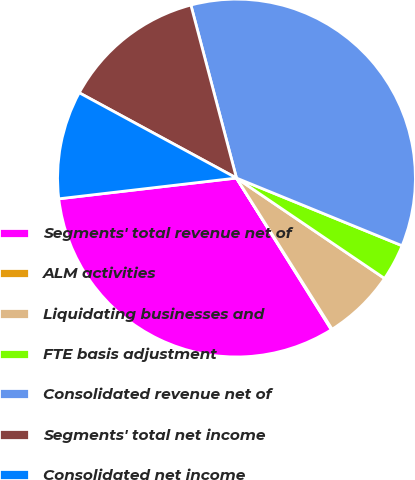<chart> <loc_0><loc_0><loc_500><loc_500><pie_chart><fcel>Segments' total revenue net of<fcel>ALM activities<fcel>Liquidating businesses and<fcel>FTE basis adjustment<fcel>Consolidated revenue net of<fcel>Segments' total net income<fcel>Consolidated net income<nl><fcel>32.05%<fcel>0.08%<fcel>6.54%<fcel>3.31%<fcel>35.28%<fcel>12.99%<fcel>9.76%<nl></chart> 